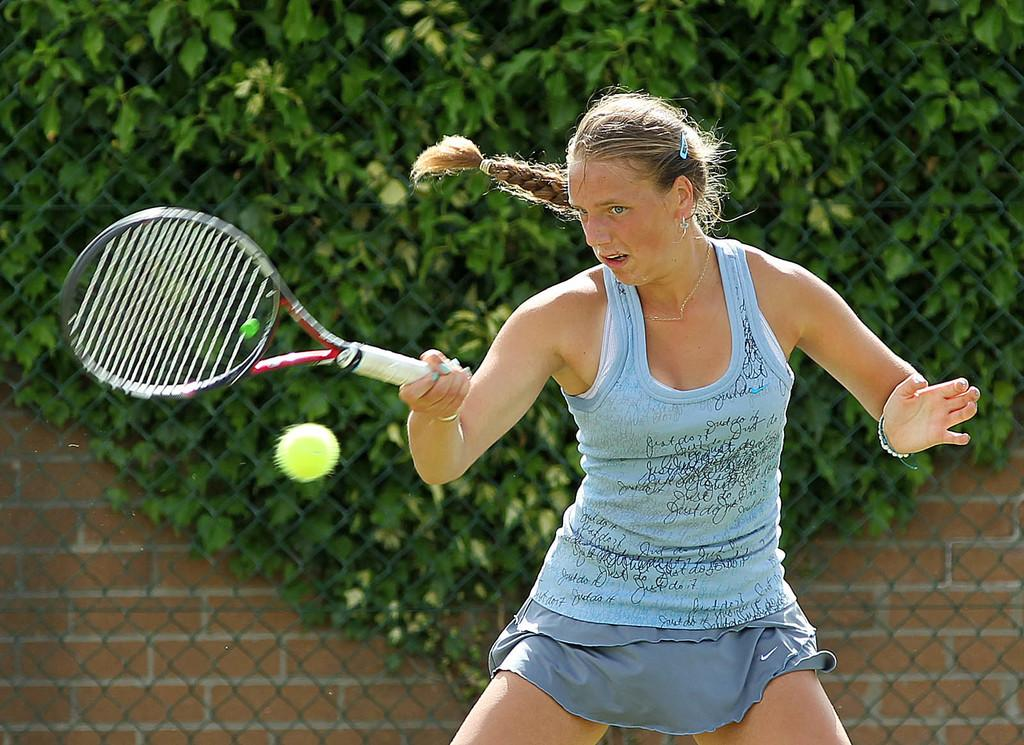What object is the person holding in their hands? The person is holding a racket in their hands. What is happening with the ball in the image? There is a ball in the air. What can be seen in the background of the image? There is a fence, a brick wall, and trees in the background. Where is the person's sister in the image? There is no mention of a sister in the provided facts, so we cannot determine her location. 